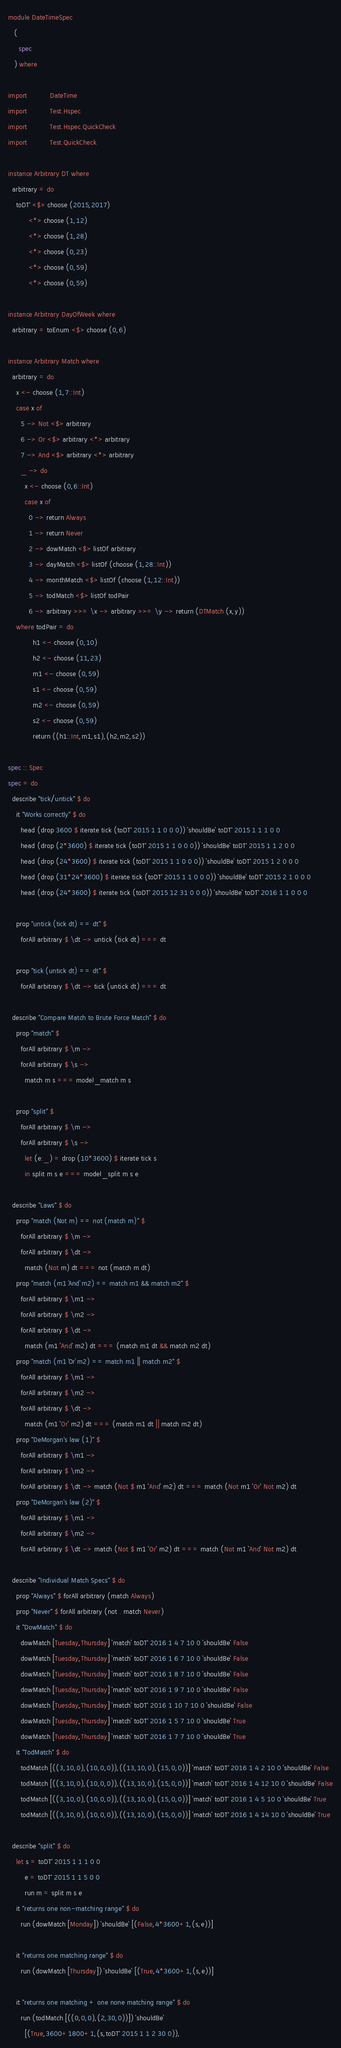<code> <loc_0><loc_0><loc_500><loc_500><_Haskell_>module DateTimeSpec
   (
     spec
   ) where

import           DateTime
import           Test.Hspec
import           Test.Hspec.QuickCheck
import           Test.QuickCheck

instance Arbitrary DT where
  arbitrary = do
    toDT' <$> choose (2015,2017)
          <*> choose (1,12)
          <*> choose (1,28)
          <*> choose (0,23)
          <*> choose (0,59)
          <*> choose (0,59)

instance Arbitrary DayOfWeek where
  arbitrary = toEnum <$> choose (0,6)

instance Arbitrary Match where
  arbitrary = do
    x <- choose (1,7::Int)
    case x of
      5 -> Not <$> arbitrary
      6 -> Or <$> arbitrary <*> arbitrary
      7 -> And <$> arbitrary <*> arbitrary
      _ -> do
        x <- choose (0,6::Int)
        case x of
          0 -> return Always
          1 -> return Never
          2 -> dowMatch <$> listOf arbitrary
          3 -> dayMatch <$> listOf (choose (1,28::Int))
          4 -> monthMatch <$> listOf (choose (1,12::Int))
          5 -> todMatch <$> listOf todPair
          6 -> arbitrary >>= \x -> arbitrary >>= \y -> return (DTMatch (x,y))
    where todPair = do
            h1 <- choose (0,10)
            h2 <- choose (11,23)
            m1 <- choose (0,59)
            s1 <- choose (0,59)
            m2 <- choose (0,59)
            s2 <- choose (0,59)
            return ((h1::Int,m1,s1),(h2,m2,s2))

spec :: Spec
spec = do
  describe "tick/untick" $ do
    it "Works correctly" $ do
      head (drop 3600 $ iterate tick (toDT' 2015 1 1 0 0 0)) `shouldBe` toDT' 2015 1 1 1 0 0
      head (drop (2*3600) $ iterate tick (toDT' 2015 1 1 0 0 0)) `shouldBe` toDT' 2015 1 1 2 0 0
      head (drop (24*3600) $ iterate tick (toDT' 2015 1 1 0 0 0)) `shouldBe` toDT' 2015 1 2 0 0 0
      head (drop (31*24*3600) $ iterate tick (toDT' 2015 1 1 0 0 0)) `shouldBe` toDT' 2015 2 1 0 0 0
      head (drop (24*3600) $ iterate tick (toDT' 2015 12 31 0 0 0)) `shouldBe` toDT' 2016 1 1 0 0 0

    prop "untick (tick dt) == dt" $
      forAll arbitrary $ \dt -> untick (tick dt) === dt

    prop "tick (untick dt) == dt" $
      forAll arbitrary $ \dt -> tick (untick dt) === dt

  describe "Compare Match to Brute Force Match" $ do
    prop "match" $
      forAll arbitrary $ \m ->
      forAll arbitrary $ \s ->
        match m s === model_match m s

    prop "split" $
      forAll arbitrary $ \m ->
      forAll arbitrary $ \s ->
        let (e:_) = drop (10*3600) $ iterate tick s
        in split m s e === model_split m s e

  describe "Laws" $ do
    prop "match (Not m) == not (match m)" $
      forAll arbitrary $ \m ->
      forAll arbitrary $ \dt ->
        match (Not m) dt === not (match m dt)
    prop "match (m1 `And` m2) == match m1 && match m2" $
      forAll arbitrary $ \m1 ->
      forAll arbitrary $ \m2 ->
      forAll arbitrary $ \dt ->
        match (m1 `And` m2) dt === (match m1 dt && match m2 dt)
    prop "match (m1 `Or` m2) == match m1 || match m2" $
      forAll arbitrary $ \m1 ->
      forAll arbitrary $ \m2 ->
      forAll arbitrary $ \dt ->
        match (m1 `Or` m2) dt === (match m1 dt || match m2 dt)
    prop "DeMorgan's law (1)" $
      forAll arbitrary $ \m1 ->
      forAll arbitrary $ \m2 ->
      forAll arbitrary $ \dt -> match (Not $ m1 `And` m2) dt === match (Not m1 `Or` Not m2) dt
    prop "DeMorgan's law (2)" $
      forAll arbitrary $ \m1 ->
      forAll arbitrary $ \m2 ->
      forAll arbitrary $ \dt -> match (Not $ m1 `Or` m2) dt === match (Not m1 `And` Not m2) dt

  describe "Individual Match Specs" $ do
    prop "Always" $ forAll arbitrary (match Always)
    prop "Never" $ forAll arbitrary (not . match Never)
    it "DowMatch" $ do
      dowMatch [Tuesday,Thursday] `match` toDT' 2016 1 4 7 10 0 `shouldBe` False
      dowMatch [Tuesday,Thursday] `match` toDT' 2016 1 6 7 10 0 `shouldBe` False
      dowMatch [Tuesday,Thursday] `match` toDT' 2016 1 8 7 10 0 `shouldBe` False
      dowMatch [Tuesday,Thursday] `match` toDT' 2016 1 9 7 10 0 `shouldBe` False
      dowMatch [Tuesday,Thursday] `match` toDT' 2016 1 10 7 10 0 `shouldBe` False
      dowMatch [Tuesday,Thursday] `match` toDT' 2016 1 5 7 10 0 `shouldBe` True
      dowMatch [Tuesday,Thursday] `match` toDT' 2016 1 7 7 10 0 `shouldBe` True
    it "TodMatch" $ do
      todMatch [((3,10,0),(10,0,0)),((13,10,0),(15,0,0))] `match` toDT' 2016 1 4 2 10 0 `shouldBe` False
      todMatch [((3,10,0),(10,0,0)),((13,10,0),(15,0,0))] `match` toDT' 2016 1 4 12 10 0 `shouldBe` False
      todMatch [((3,10,0),(10,0,0)),((13,10,0),(15,0,0))] `match` toDT' 2016 1 4 5 10 0 `shouldBe` True
      todMatch [((3,10,0),(10,0,0)),((13,10,0),(15,0,0))] `match` toDT' 2016 1 4 14 10 0 `shouldBe` True

  describe "split" $ do
    let s = toDT' 2015 1 1 1 0 0
        e = toDT' 2015 1 1 5 0 0
        run m = split m s e
    it "returns one non-matching range" $ do
      run (dowMatch [Monday]) `shouldBe` [(False,4*3600+1,(s,e))]

    it "returns one matching range" $ do
      run (dowMatch [Thursday]) `shouldBe` [(True,4*3600+1,(s,e))]

    it "returns one matching + one none matching range" $ do
      run (todMatch [((0,0,0),(2,30,0))]) `shouldBe`
        [(True,3600+1800+1,(s,toDT' 2015 1 1 2 30 0)),</code> 